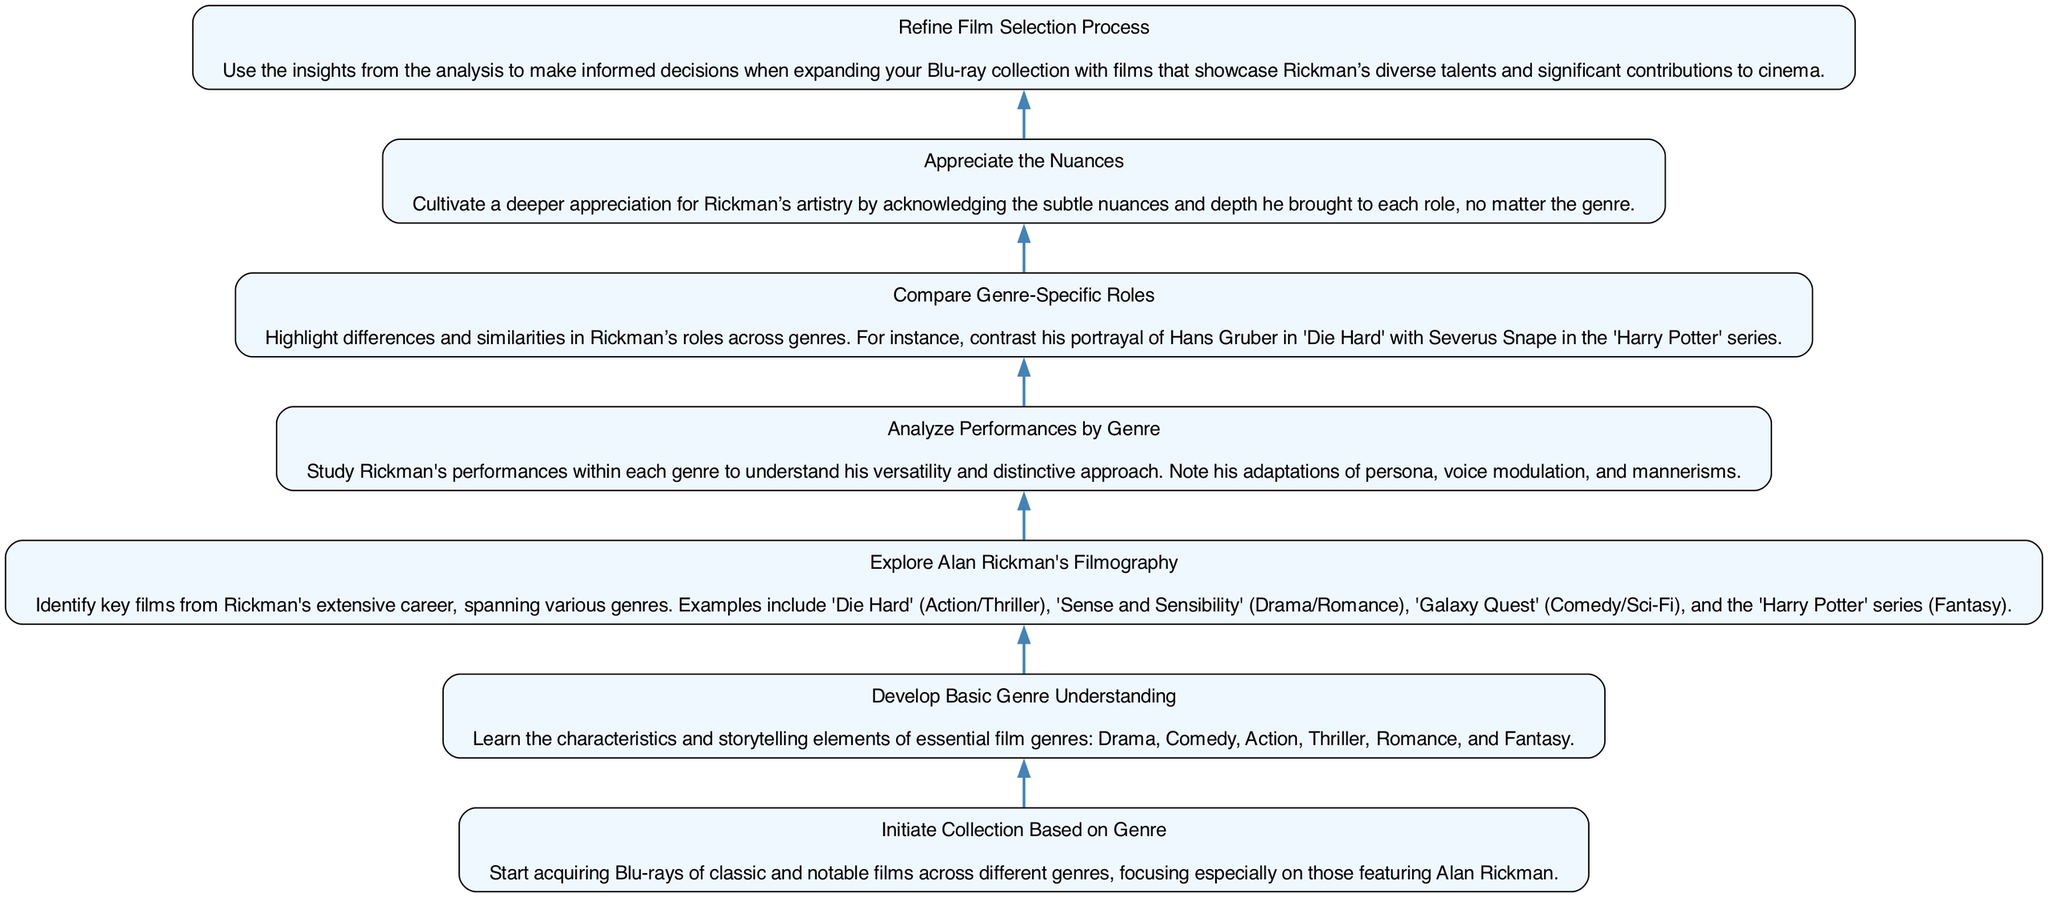What is the first step in the flow chart? The first step in the flow chart is "Initiate Collection Based on Genre" which is shown as the lowest node in the diagram.
Answer: Initiate Collection Based on Genre How many nodes are there in the flow chart? The flow chart consists of seven nodes that represent the different steps in the process of understanding film genres through Alan Rickman's performances.
Answer: 7 What is the last step in the flow chart? The last step in the flow chart is "Refine Film Selection Process" which is located at the top of the diagram, indicating it is the final outcome of the process.
Answer: Refine Film Selection Process Which node follows "Explore Alan Rickman's Filmography"? The node that follows "Explore Alan Rickman's Filmography" is "Analyze Performances by Genre", creating a sequential flow from identifying films to analyzing performances.
Answer: Analyze Performances by Genre What are the two nodes connected to "Appreciate the Nuances"? "Appreciate the Nuances" is directly connected to "Compare Genre-Specific Roles" below it and "Refine Film Selection Process" above it, illustrating its position in the flow.
Answer: Compare Genre-Specific Roles, Refine Film Selection Process What is the relationship between "Analyze Performances by Genre" and "Develop Basic Genre Understanding"? "Analyze Performances by Genre" is positioned above "Develop Basic Genre Understanding" in the flow, indicating that analyzing performances is preceded by developing a basic understanding of different genres.
Answer: Analyze Performances by Genre is above Develop Basic Genre Understanding How does "Refine Film Selection Process" relate to other nodes in the flow? "Refine Film Selection Process" is the highest node and receives insights from the preceding nodes, particularly after "Appreciate the Nuances", indicating it is the culmination of all prior analyses and understandings.
Answer: It is the culmination of all prior analyses 